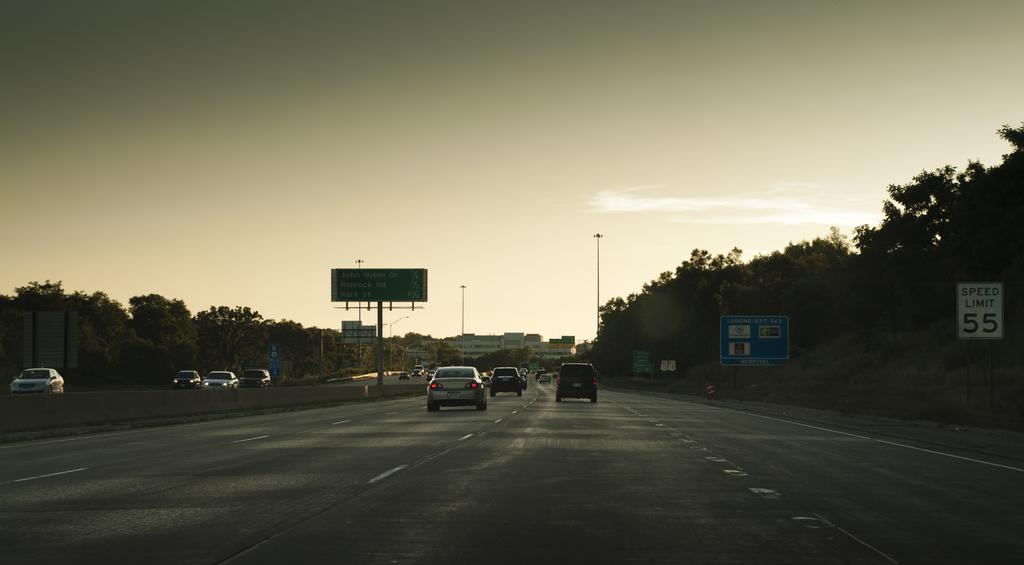What is happening on the roads in the image? There are cars moving on the roads in the image. What can be found on the boards in the image? There are boards with text in the image. What type of vegetation is present in the image? There are trees in the image. What structures can be seen in the image? There are poles in the image. How would you describe the weather in the image? The sky is cloudy in the image. Can you tell me how many deer are visible in the image? There are no deer present in the image. What question is being asked on the boards in the image? The boards in the image have text, but we cannot determine the specific question being asked without more information. 